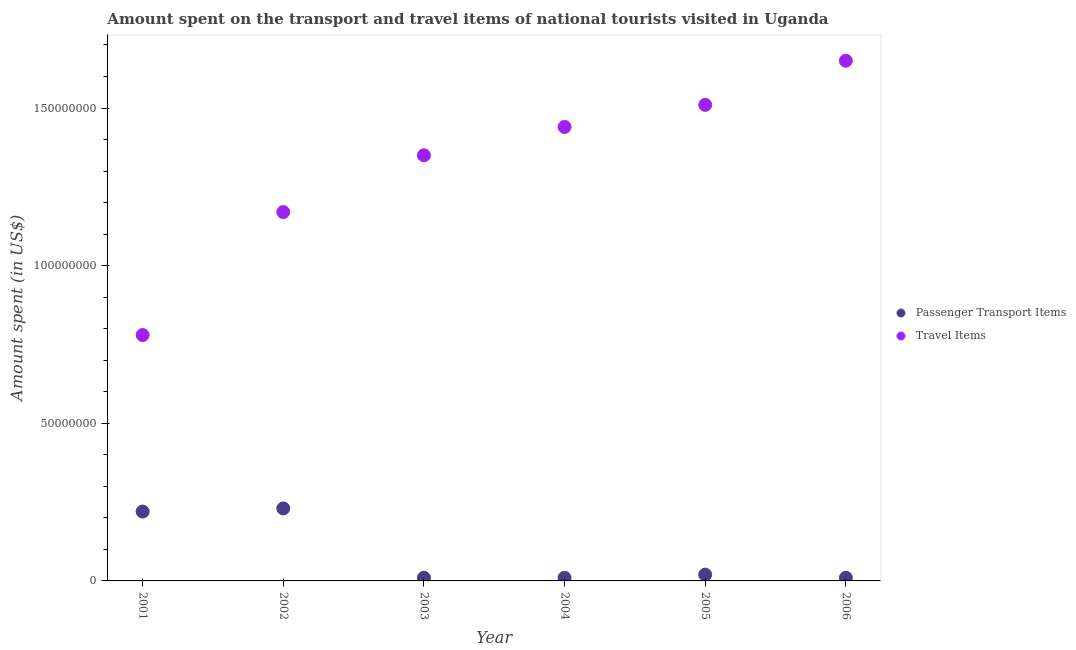How many different coloured dotlines are there?
Offer a terse response. 2. What is the amount spent in travel items in 2003?
Give a very brief answer. 1.35e+08. Across all years, what is the maximum amount spent on passenger transport items?
Your answer should be very brief. 2.30e+07. Across all years, what is the minimum amount spent in travel items?
Make the answer very short. 7.80e+07. In which year was the amount spent on passenger transport items maximum?
Give a very brief answer. 2002. What is the total amount spent in travel items in the graph?
Your answer should be compact. 7.90e+08. What is the difference between the amount spent on passenger transport items in 2002 and that in 2005?
Give a very brief answer. 2.10e+07. What is the difference between the amount spent in travel items in 2001 and the amount spent on passenger transport items in 2005?
Make the answer very short. 7.60e+07. What is the average amount spent on passenger transport items per year?
Your answer should be compact. 8.33e+06. In the year 2002, what is the difference between the amount spent in travel items and amount spent on passenger transport items?
Provide a short and direct response. 9.40e+07. In how many years, is the amount spent on passenger transport items greater than 30000000 US$?
Your answer should be compact. 0. What is the difference between the highest and the second highest amount spent in travel items?
Your response must be concise. 1.40e+07. What is the difference between the highest and the lowest amount spent in travel items?
Provide a succinct answer. 8.70e+07. In how many years, is the amount spent on passenger transport items greater than the average amount spent on passenger transport items taken over all years?
Your response must be concise. 2. Is the amount spent in travel items strictly less than the amount spent on passenger transport items over the years?
Offer a very short reply. No. How many dotlines are there?
Provide a short and direct response. 2. What is the difference between two consecutive major ticks on the Y-axis?
Ensure brevity in your answer.  5.00e+07. Does the graph contain any zero values?
Provide a short and direct response. No. How many legend labels are there?
Ensure brevity in your answer.  2. How are the legend labels stacked?
Your answer should be compact. Vertical. What is the title of the graph?
Make the answer very short. Amount spent on the transport and travel items of national tourists visited in Uganda. What is the label or title of the X-axis?
Your answer should be very brief. Year. What is the label or title of the Y-axis?
Make the answer very short. Amount spent (in US$). What is the Amount spent (in US$) of Passenger Transport Items in 2001?
Ensure brevity in your answer.  2.20e+07. What is the Amount spent (in US$) of Travel Items in 2001?
Your answer should be very brief. 7.80e+07. What is the Amount spent (in US$) of Passenger Transport Items in 2002?
Make the answer very short. 2.30e+07. What is the Amount spent (in US$) of Travel Items in 2002?
Provide a succinct answer. 1.17e+08. What is the Amount spent (in US$) in Travel Items in 2003?
Keep it short and to the point. 1.35e+08. What is the Amount spent (in US$) in Passenger Transport Items in 2004?
Keep it short and to the point. 1.00e+06. What is the Amount spent (in US$) of Travel Items in 2004?
Your answer should be very brief. 1.44e+08. What is the Amount spent (in US$) of Passenger Transport Items in 2005?
Make the answer very short. 2.00e+06. What is the Amount spent (in US$) in Travel Items in 2005?
Provide a short and direct response. 1.51e+08. What is the Amount spent (in US$) in Travel Items in 2006?
Your response must be concise. 1.65e+08. Across all years, what is the maximum Amount spent (in US$) in Passenger Transport Items?
Offer a very short reply. 2.30e+07. Across all years, what is the maximum Amount spent (in US$) in Travel Items?
Offer a very short reply. 1.65e+08. Across all years, what is the minimum Amount spent (in US$) in Travel Items?
Make the answer very short. 7.80e+07. What is the total Amount spent (in US$) in Travel Items in the graph?
Ensure brevity in your answer.  7.90e+08. What is the difference between the Amount spent (in US$) of Passenger Transport Items in 2001 and that in 2002?
Keep it short and to the point. -1.00e+06. What is the difference between the Amount spent (in US$) of Travel Items in 2001 and that in 2002?
Provide a short and direct response. -3.90e+07. What is the difference between the Amount spent (in US$) of Passenger Transport Items in 2001 and that in 2003?
Ensure brevity in your answer.  2.10e+07. What is the difference between the Amount spent (in US$) of Travel Items in 2001 and that in 2003?
Offer a very short reply. -5.70e+07. What is the difference between the Amount spent (in US$) in Passenger Transport Items in 2001 and that in 2004?
Keep it short and to the point. 2.10e+07. What is the difference between the Amount spent (in US$) in Travel Items in 2001 and that in 2004?
Ensure brevity in your answer.  -6.60e+07. What is the difference between the Amount spent (in US$) of Passenger Transport Items in 2001 and that in 2005?
Provide a succinct answer. 2.00e+07. What is the difference between the Amount spent (in US$) of Travel Items in 2001 and that in 2005?
Make the answer very short. -7.30e+07. What is the difference between the Amount spent (in US$) of Passenger Transport Items in 2001 and that in 2006?
Your answer should be compact. 2.10e+07. What is the difference between the Amount spent (in US$) in Travel Items in 2001 and that in 2006?
Your answer should be compact. -8.70e+07. What is the difference between the Amount spent (in US$) in Passenger Transport Items in 2002 and that in 2003?
Provide a succinct answer. 2.20e+07. What is the difference between the Amount spent (in US$) in Travel Items in 2002 and that in 2003?
Your answer should be very brief. -1.80e+07. What is the difference between the Amount spent (in US$) of Passenger Transport Items in 2002 and that in 2004?
Offer a terse response. 2.20e+07. What is the difference between the Amount spent (in US$) of Travel Items in 2002 and that in 2004?
Provide a succinct answer. -2.70e+07. What is the difference between the Amount spent (in US$) of Passenger Transport Items in 2002 and that in 2005?
Give a very brief answer. 2.10e+07. What is the difference between the Amount spent (in US$) of Travel Items in 2002 and that in 2005?
Offer a terse response. -3.40e+07. What is the difference between the Amount spent (in US$) in Passenger Transport Items in 2002 and that in 2006?
Offer a very short reply. 2.20e+07. What is the difference between the Amount spent (in US$) of Travel Items in 2002 and that in 2006?
Your answer should be compact. -4.80e+07. What is the difference between the Amount spent (in US$) in Passenger Transport Items in 2003 and that in 2004?
Your response must be concise. 0. What is the difference between the Amount spent (in US$) of Travel Items in 2003 and that in 2004?
Provide a succinct answer. -9.00e+06. What is the difference between the Amount spent (in US$) in Passenger Transport Items in 2003 and that in 2005?
Your answer should be very brief. -1.00e+06. What is the difference between the Amount spent (in US$) of Travel Items in 2003 and that in 2005?
Your answer should be compact. -1.60e+07. What is the difference between the Amount spent (in US$) in Travel Items in 2003 and that in 2006?
Provide a succinct answer. -3.00e+07. What is the difference between the Amount spent (in US$) in Travel Items in 2004 and that in 2005?
Make the answer very short. -7.00e+06. What is the difference between the Amount spent (in US$) of Passenger Transport Items in 2004 and that in 2006?
Offer a very short reply. 0. What is the difference between the Amount spent (in US$) in Travel Items in 2004 and that in 2006?
Keep it short and to the point. -2.10e+07. What is the difference between the Amount spent (in US$) in Travel Items in 2005 and that in 2006?
Give a very brief answer. -1.40e+07. What is the difference between the Amount spent (in US$) of Passenger Transport Items in 2001 and the Amount spent (in US$) of Travel Items in 2002?
Offer a terse response. -9.50e+07. What is the difference between the Amount spent (in US$) in Passenger Transport Items in 2001 and the Amount spent (in US$) in Travel Items in 2003?
Ensure brevity in your answer.  -1.13e+08. What is the difference between the Amount spent (in US$) in Passenger Transport Items in 2001 and the Amount spent (in US$) in Travel Items in 2004?
Make the answer very short. -1.22e+08. What is the difference between the Amount spent (in US$) of Passenger Transport Items in 2001 and the Amount spent (in US$) of Travel Items in 2005?
Your answer should be very brief. -1.29e+08. What is the difference between the Amount spent (in US$) in Passenger Transport Items in 2001 and the Amount spent (in US$) in Travel Items in 2006?
Provide a short and direct response. -1.43e+08. What is the difference between the Amount spent (in US$) of Passenger Transport Items in 2002 and the Amount spent (in US$) of Travel Items in 2003?
Provide a succinct answer. -1.12e+08. What is the difference between the Amount spent (in US$) in Passenger Transport Items in 2002 and the Amount spent (in US$) in Travel Items in 2004?
Give a very brief answer. -1.21e+08. What is the difference between the Amount spent (in US$) of Passenger Transport Items in 2002 and the Amount spent (in US$) of Travel Items in 2005?
Make the answer very short. -1.28e+08. What is the difference between the Amount spent (in US$) in Passenger Transport Items in 2002 and the Amount spent (in US$) in Travel Items in 2006?
Ensure brevity in your answer.  -1.42e+08. What is the difference between the Amount spent (in US$) of Passenger Transport Items in 2003 and the Amount spent (in US$) of Travel Items in 2004?
Offer a terse response. -1.43e+08. What is the difference between the Amount spent (in US$) in Passenger Transport Items in 2003 and the Amount spent (in US$) in Travel Items in 2005?
Your answer should be compact. -1.50e+08. What is the difference between the Amount spent (in US$) of Passenger Transport Items in 2003 and the Amount spent (in US$) of Travel Items in 2006?
Your answer should be very brief. -1.64e+08. What is the difference between the Amount spent (in US$) of Passenger Transport Items in 2004 and the Amount spent (in US$) of Travel Items in 2005?
Your answer should be very brief. -1.50e+08. What is the difference between the Amount spent (in US$) of Passenger Transport Items in 2004 and the Amount spent (in US$) of Travel Items in 2006?
Offer a very short reply. -1.64e+08. What is the difference between the Amount spent (in US$) of Passenger Transport Items in 2005 and the Amount spent (in US$) of Travel Items in 2006?
Provide a short and direct response. -1.63e+08. What is the average Amount spent (in US$) of Passenger Transport Items per year?
Provide a short and direct response. 8.33e+06. What is the average Amount spent (in US$) in Travel Items per year?
Keep it short and to the point. 1.32e+08. In the year 2001, what is the difference between the Amount spent (in US$) of Passenger Transport Items and Amount spent (in US$) of Travel Items?
Ensure brevity in your answer.  -5.60e+07. In the year 2002, what is the difference between the Amount spent (in US$) in Passenger Transport Items and Amount spent (in US$) in Travel Items?
Give a very brief answer. -9.40e+07. In the year 2003, what is the difference between the Amount spent (in US$) in Passenger Transport Items and Amount spent (in US$) in Travel Items?
Keep it short and to the point. -1.34e+08. In the year 2004, what is the difference between the Amount spent (in US$) of Passenger Transport Items and Amount spent (in US$) of Travel Items?
Ensure brevity in your answer.  -1.43e+08. In the year 2005, what is the difference between the Amount spent (in US$) of Passenger Transport Items and Amount spent (in US$) of Travel Items?
Provide a succinct answer. -1.49e+08. In the year 2006, what is the difference between the Amount spent (in US$) in Passenger Transport Items and Amount spent (in US$) in Travel Items?
Your answer should be compact. -1.64e+08. What is the ratio of the Amount spent (in US$) of Passenger Transport Items in 2001 to that in 2002?
Make the answer very short. 0.96. What is the ratio of the Amount spent (in US$) of Travel Items in 2001 to that in 2002?
Give a very brief answer. 0.67. What is the ratio of the Amount spent (in US$) in Passenger Transport Items in 2001 to that in 2003?
Offer a very short reply. 22. What is the ratio of the Amount spent (in US$) in Travel Items in 2001 to that in 2003?
Your answer should be compact. 0.58. What is the ratio of the Amount spent (in US$) in Passenger Transport Items in 2001 to that in 2004?
Your response must be concise. 22. What is the ratio of the Amount spent (in US$) of Travel Items in 2001 to that in 2004?
Ensure brevity in your answer.  0.54. What is the ratio of the Amount spent (in US$) in Passenger Transport Items in 2001 to that in 2005?
Ensure brevity in your answer.  11. What is the ratio of the Amount spent (in US$) of Travel Items in 2001 to that in 2005?
Provide a succinct answer. 0.52. What is the ratio of the Amount spent (in US$) in Travel Items in 2001 to that in 2006?
Provide a short and direct response. 0.47. What is the ratio of the Amount spent (in US$) in Passenger Transport Items in 2002 to that in 2003?
Offer a terse response. 23. What is the ratio of the Amount spent (in US$) of Travel Items in 2002 to that in 2003?
Keep it short and to the point. 0.87. What is the ratio of the Amount spent (in US$) in Travel Items in 2002 to that in 2004?
Your answer should be compact. 0.81. What is the ratio of the Amount spent (in US$) of Travel Items in 2002 to that in 2005?
Your answer should be very brief. 0.77. What is the ratio of the Amount spent (in US$) of Passenger Transport Items in 2002 to that in 2006?
Provide a short and direct response. 23. What is the ratio of the Amount spent (in US$) of Travel Items in 2002 to that in 2006?
Your response must be concise. 0.71. What is the ratio of the Amount spent (in US$) in Travel Items in 2003 to that in 2005?
Give a very brief answer. 0.89. What is the ratio of the Amount spent (in US$) of Passenger Transport Items in 2003 to that in 2006?
Your answer should be compact. 1. What is the ratio of the Amount spent (in US$) in Travel Items in 2003 to that in 2006?
Ensure brevity in your answer.  0.82. What is the ratio of the Amount spent (in US$) of Passenger Transport Items in 2004 to that in 2005?
Keep it short and to the point. 0.5. What is the ratio of the Amount spent (in US$) in Travel Items in 2004 to that in 2005?
Make the answer very short. 0.95. What is the ratio of the Amount spent (in US$) of Travel Items in 2004 to that in 2006?
Your response must be concise. 0.87. What is the ratio of the Amount spent (in US$) of Passenger Transport Items in 2005 to that in 2006?
Your answer should be very brief. 2. What is the ratio of the Amount spent (in US$) of Travel Items in 2005 to that in 2006?
Your answer should be compact. 0.92. What is the difference between the highest and the second highest Amount spent (in US$) of Travel Items?
Give a very brief answer. 1.40e+07. What is the difference between the highest and the lowest Amount spent (in US$) of Passenger Transport Items?
Offer a very short reply. 2.20e+07. What is the difference between the highest and the lowest Amount spent (in US$) of Travel Items?
Provide a short and direct response. 8.70e+07. 